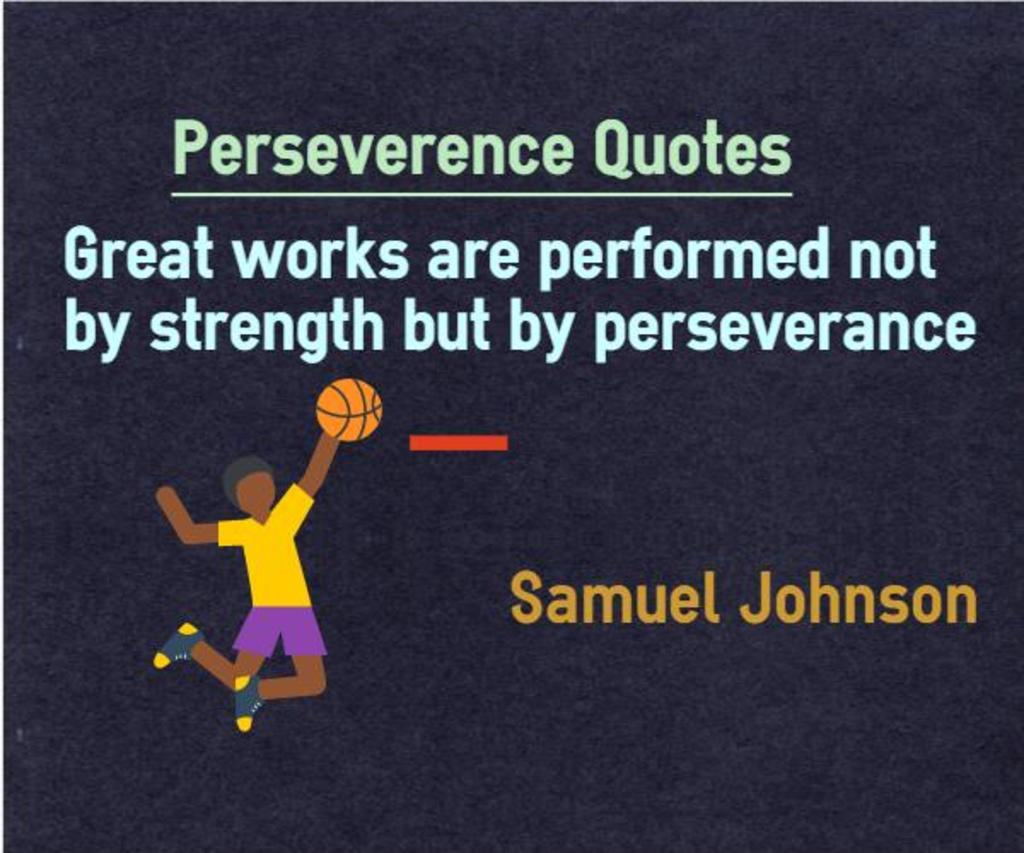What is the main subject of the image? There is a picture of a person in the image. What other object can be seen in the image? There is a ball in the image. Are there any words or letters in the image? Yes, there is text present in the image. What type of pest can be seen crawling on the person in the image? There is no pest visible in the image; it only features a person and a ball. How many pins are attached to the person in the image? There are no pins present in the image. 